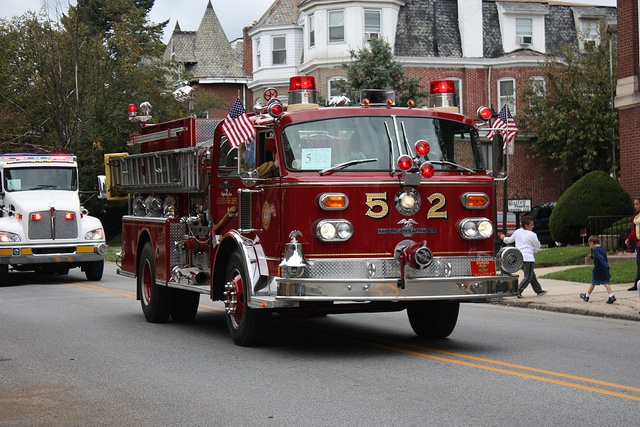Describe the objects in this image and their specific colors. I can see truck in lavender, black, maroon, gray, and darkgray tones, truck in lavender, lightgray, gray, black, and darkgray tones, people in lavender, gray, darkgray, and black tones, people in lavender, black, darkgray, and gray tones, and people in lavender, black, navy, and gray tones in this image. 